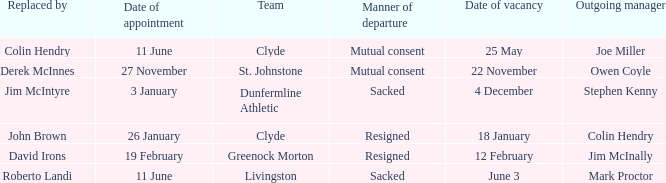Tell me the outgoing manager for livingston Mark Proctor. 